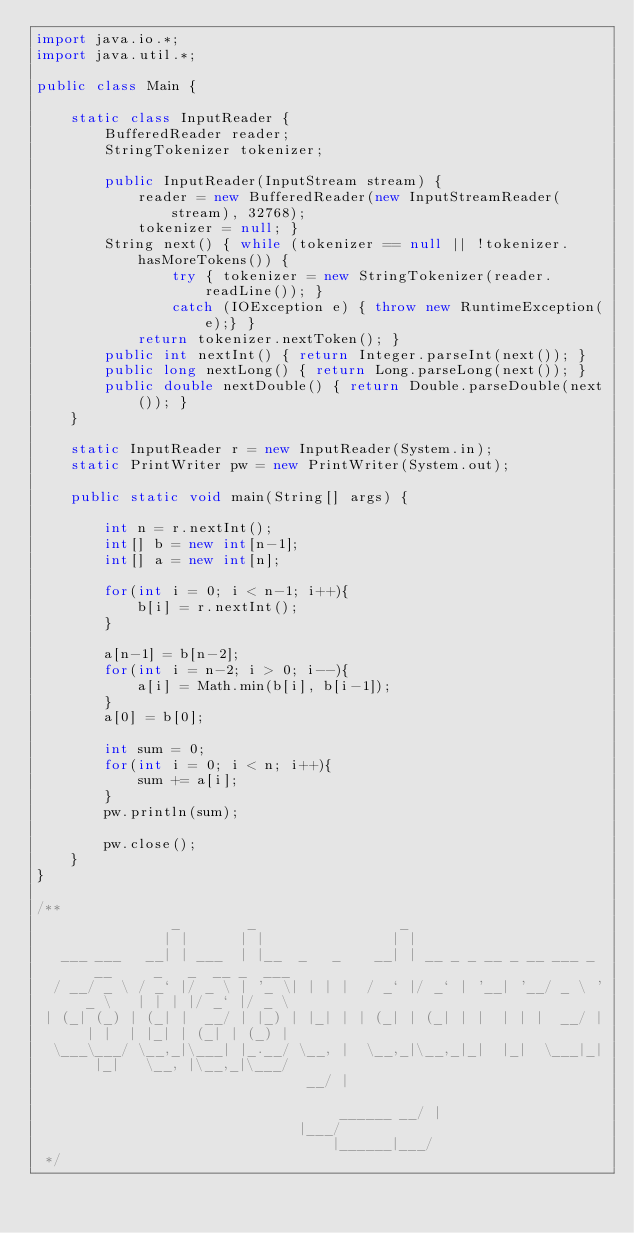<code> <loc_0><loc_0><loc_500><loc_500><_Java_>import java.io.*;
import java.util.*;

public class Main {

    static class InputReader {
        BufferedReader reader;
        StringTokenizer tokenizer;

        public InputReader(InputStream stream) {
            reader = new BufferedReader(new InputStreamReader(stream), 32768);
            tokenizer = null; }
        String next() { while (tokenizer == null || !tokenizer.hasMoreTokens()) {
                try { tokenizer = new StringTokenizer(reader.readLine()); } 
                catch (IOException e) { throw new RuntimeException(e);} }
            return tokenizer.nextToken(); }
        public int nextInt() { return Integer.parseInt(next()); }
        public long nextLong() { return Long.parseLong(next()); }
        public double nextDouble() { return Double.parseDouble(next()); }
    }

    static InputReader r = new InputReader(System.in);
    static PrintWriter pw = new PrintWriter(System.out);

    public static void main(String[] args) {
        
        int n = r.nextInt();
        int[] b = new int[n-1];
        int[] a = new int[n];

        for(int i = 0; i < n-1; i++){
            b[i] = r.nextInt();
        }

        a[n-1] = b[n-2];
        for(int i = n-2; i > 0; i--){
            a[i] = Math.min(b[i], b[i-1]);
        }
        a[0] = b[0];

        int sum = 0;
        for(int i = 0; i < n; i++){
            sum += a[i];
        }
        pw.println(sum);

        pw.close();
    }
}

/**
                _        _                 _                                                
               | |      | |               | |                                               
   ___ ___   __| | ___  | |__  _   _    __| | __ _ _ __ _ __ ___ _ __     _   _  __ _  ___  
  / __/ _ \ / _` |/ _ \ | '_ \| | | |  / _` |/ _` | '__| '__/ _ \ '_ \   | | | |/ _` |/ _ \ 
 | (_| (_) | (_| |  __/ | |_) | |_| | | (_| | (_| | |  | | |  __/ | | |  | |_| | (_| | (_) |
  \___\___/ \__,_|\___| |_.__/ \__, |  \__,_|\__,_|_|  |_|  \___|_| |_|   \__, |\__,_|\___/ 
                                __/ |                               ______ __/ |            
                               |___/                               |______|___/             
 */</code> 